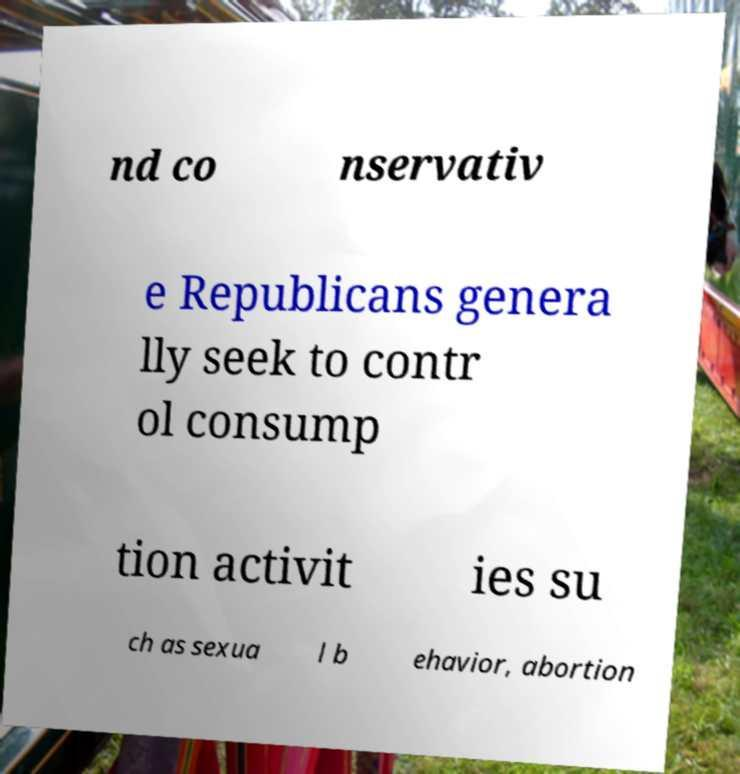Please identify and transcribe the text found in this image. nd co nservativ e Republicans genera lly seek to contr ol consump tion activit ies su ch as sexua l b ehavior, abortion 